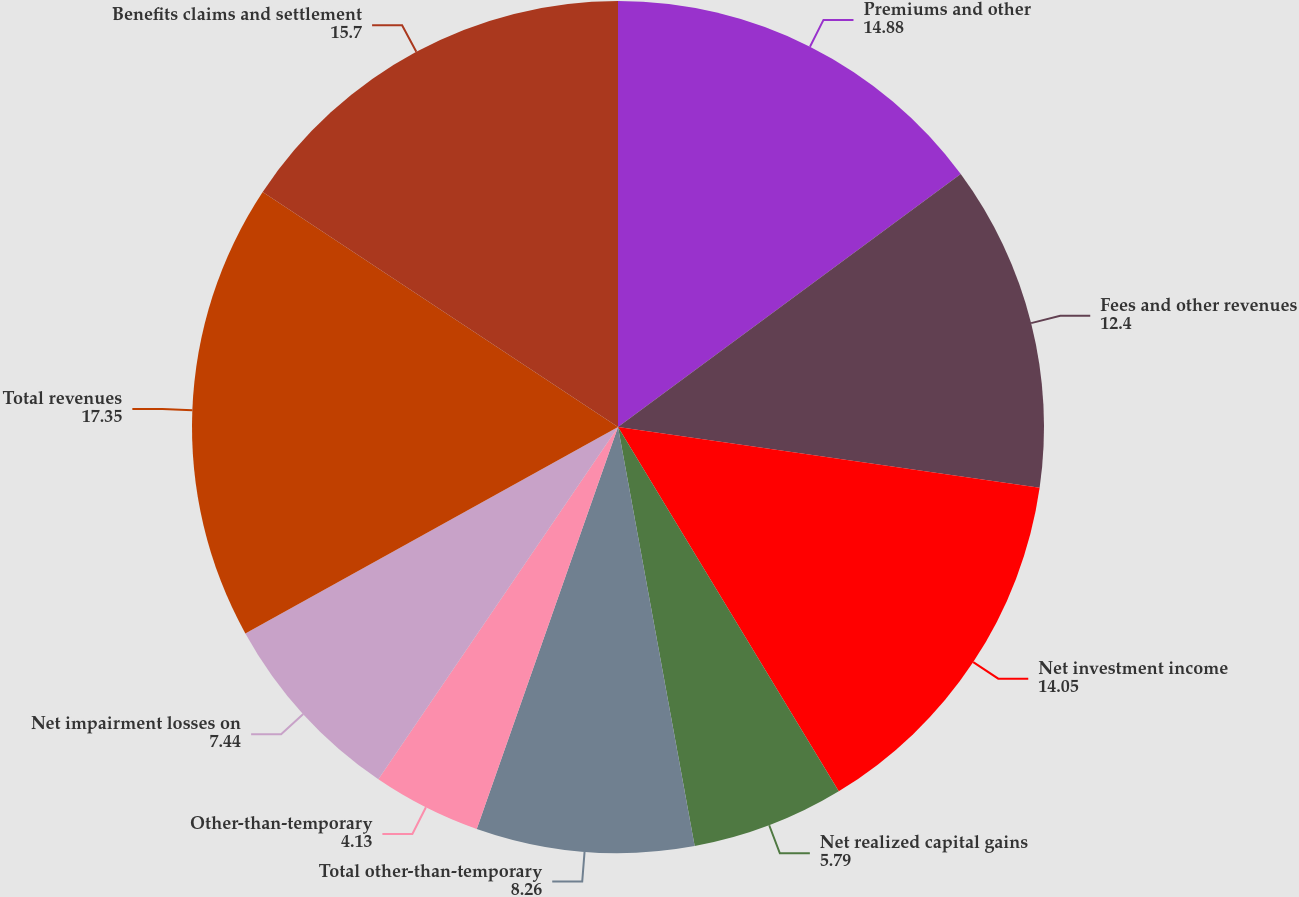Convert chart to OTSL. <chart><loc_0><loc_0><loc_500><loc_500><pie_chart><fcel>Premiums and other<fcel>Fees and other revenues<fcel>Net investment income<fcel>Net realized capital gains<fcel>Total other-than-temporary<fcel>Other-than-temporary<fcel>Net impairment losses on<fcel>Total revenues<fcel>Benefits claims and settlement<nl><fcel>14.88%<fcel>12.4%<fcel>14.05%<fcel>5.79%<fcel>8.26%<fcel>4.13%<fcel>7.44%<fcel>17.35%<fcel>15.7%<nl></chart> 